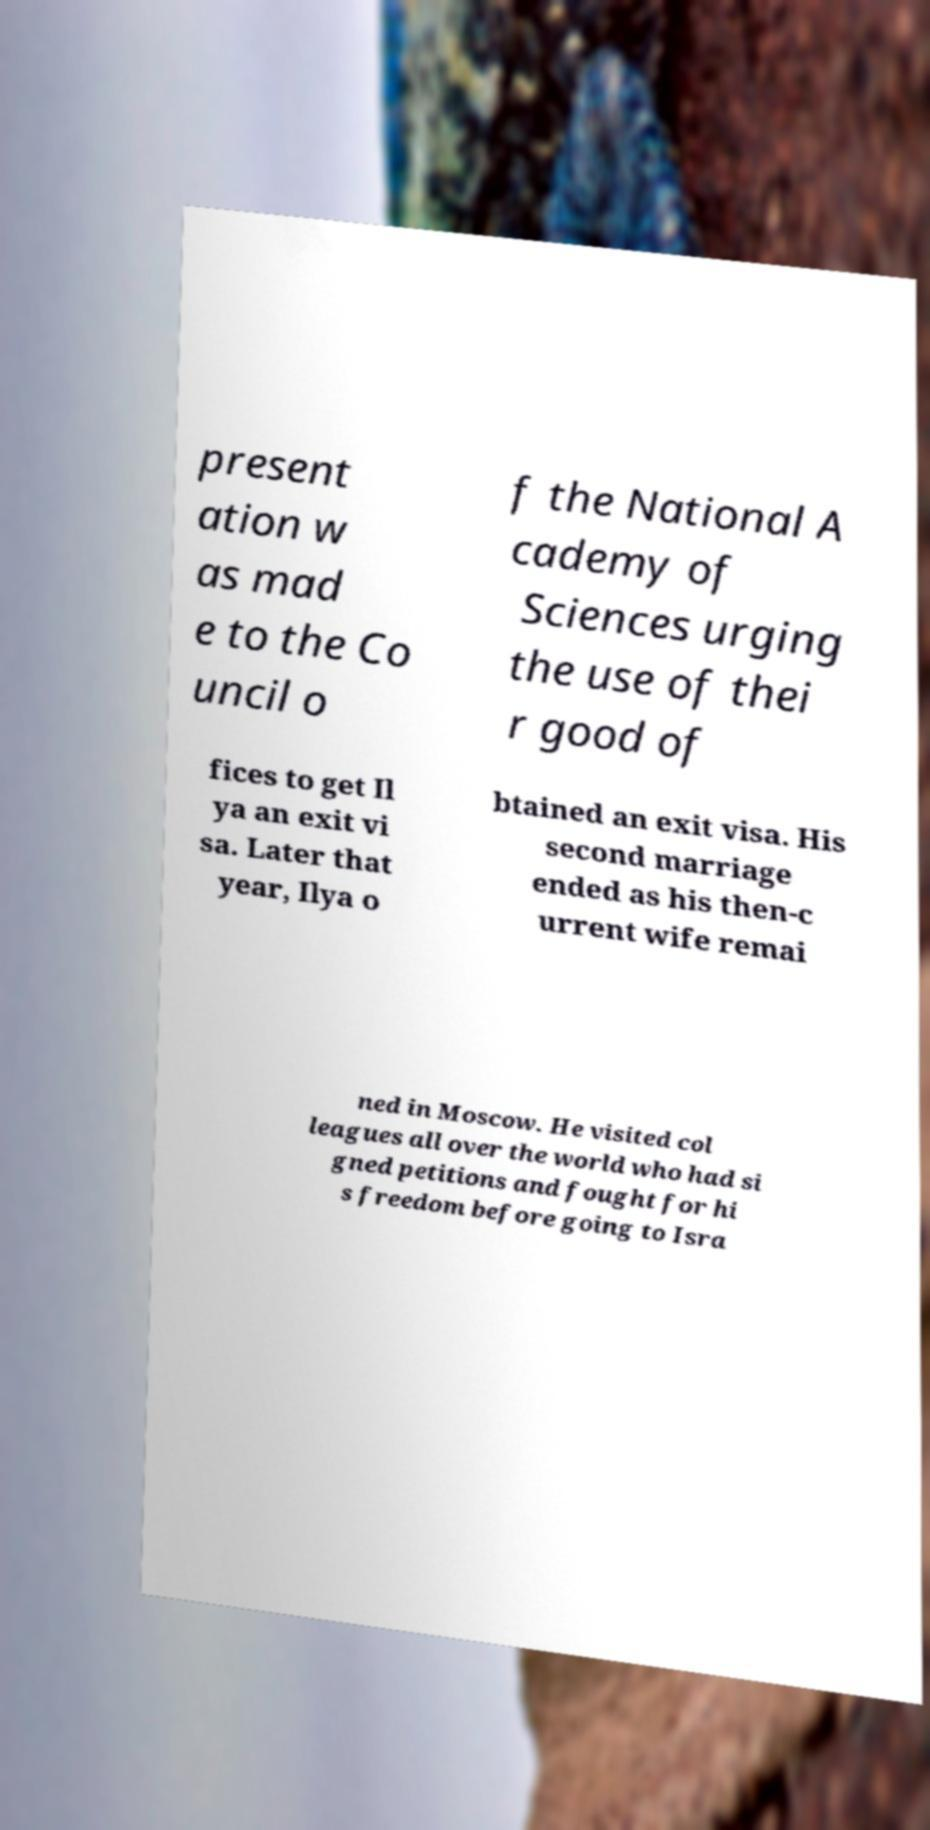Please identify and transcribe the text found in this image. present ation w as mad e to the Co uncil o f the National A cademy of Sciences urging the use of thei r good of fices to get Il ya an exit vi sa. Later that year, Ilya o btained an exit visa. His second marriage ended as his then-c urrent wife remai ned in Moscow. He visited col leagues all over the world who had si gned petitions and fought for hi s freedom before going to Isra 